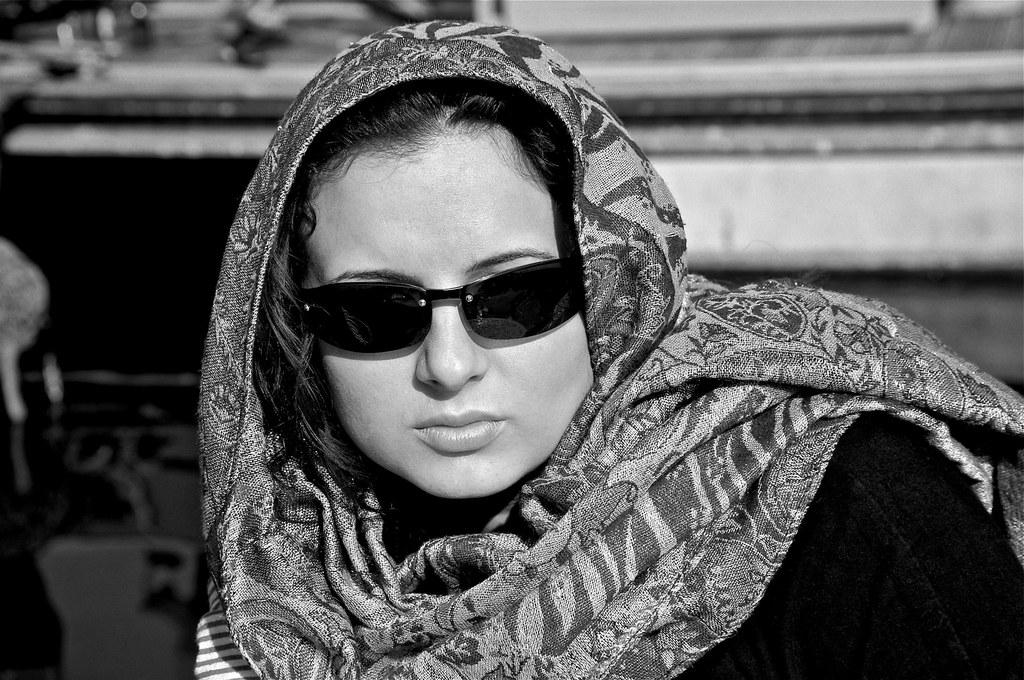What is the color scheme of the image? The image is black and white. Who is present in the image? There are women in the image. What are the women wearing in the image? The women are wearing spectacles in the image. What type of bone can be seen in the image? There is no bone present in the image; it features women wearing spectacles in a black and white setting. 